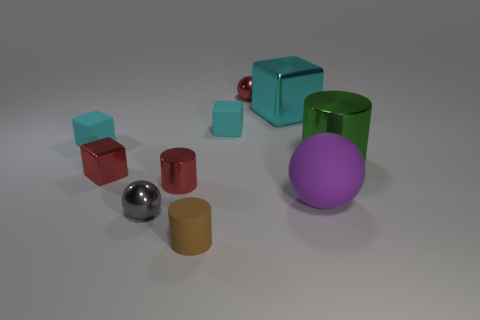How many cyan cubes must be subtracted to get 1 cyan cubes? 2 Subtract all brown spheres. How many cyan cubes are left? 3 Subtract all spheres. How many objects are left? 7 Add 2 green metallic objects. How many green metallic objects are left? 3 Add 3 tiny red shiny cylinders. How many tiny red shiny cylinders exist? 4 Subtract 0 yellow spheres. How many objects are left? 10 Subtract all blue objects. Subtract all large cyan metallic blocks. How many objects are left? 9 